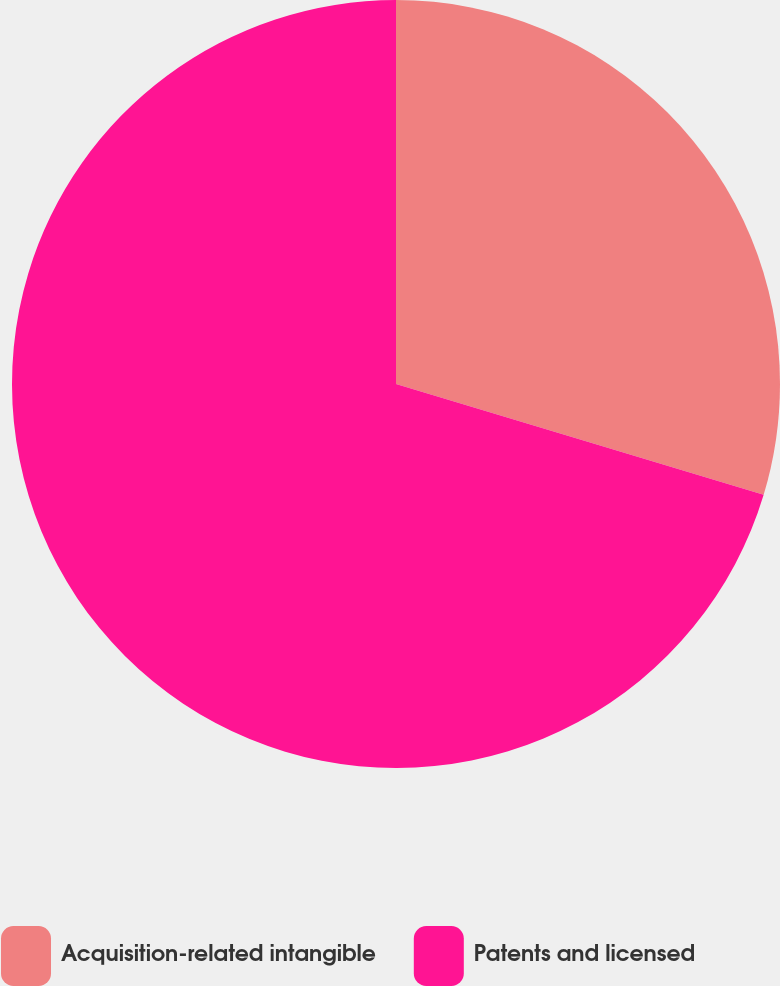Convert chart. <chart><loc_0><loc_0><loc_500><loc_500><pie_chart><fcel>Acquisition-related intangible<fcel>Patents and licensed<nl><fcel>29.66%<fcel>70.34%<nl></chart> 